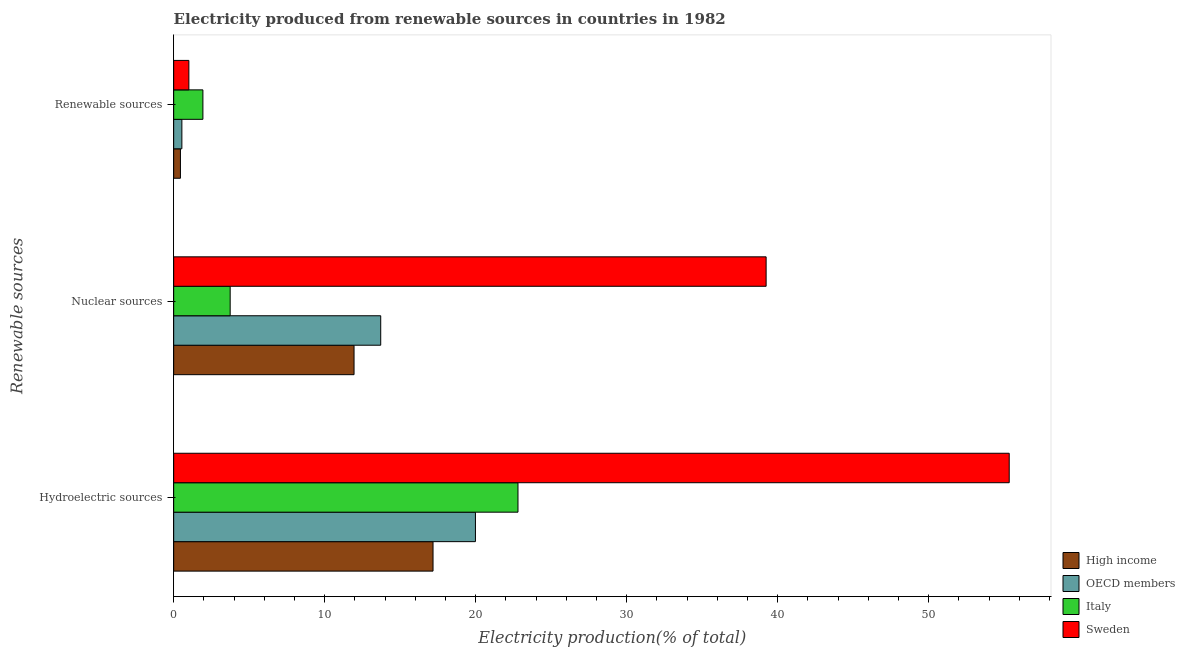How many groups of bars are there?
Make the answer very short. 3. Are the number of bars per tick equal to the number of legend labels?
Keep it short and to the point. Yes. Are the number of bars on each tick of the Y-axis equal?
Keep it short and to the point. Yes. How many bars are there on the 3rd tick from the top?
Provide a succinct answer. 4. How many bars are there on the 3rd tick from the bottom?
Keep it short and to the point. 4. What is the label of the 2nd group of bars from the top?
Give a very brief answer. Nuclear sources. What is the percentage of electricity produced by nuclear sources in OECD members?
Offer a very short reply. 13.71. Across all countries, what is the maximum percentage of electricity produced by nuclear sources?
Offer a terse response. 39.24. Across all countries, what is the minimum percentage of electricity produced by nuclear sources?
Your answer should be compact. 3.74. What is the total percentage of electricity produced by nuclear sources in the graph?
Your answer should be compact. 68.64. What is the difference between the percentage of electricity produced by hydroelectric sources in High income and that in Italy?
Your answer should be very brief. -5.63. What is the difference between the percentage of electricity produced by hydroelectric sources in High income and the percentage of electricity produced by renewable sources in Italy?
Ensure brevity in your answer.  15.24. What is the average percentage of electricity produced by nuclear sources per country?
Give a very brief answer. 17.16. What is the difference between the percentage of electricity produced by renewable sources and percentage of electricity produced by nuclear sources in OECD members?
Ensure brevity in your answer.  -13.17. What is the ratio of the percentage of electricity produced by renewable sources in Sweden to that in Italy?
Provide a short and direct response. 0.52. Is the difference between the percentage of electricity produced by hydroelectric sources in OECD members and Italy greater than the difference between the percentage of electricity produced by nuclear sources in OECD members and Italy?
Your answer should be compact. No. What is the difference between the highest and the second highest percentage of electricity produced by nuclear sources?
Provide a short and direct response. 25.52. What is the difference between the highest and the lowest percentage of electricity produced by nuclear sources?
Your response must be concise. 35.49. In how many countries, is the percentage of electricity produced by renewable sources greater than the average percentage of electricity produced by renewable sources taken over all countries?
Make the answer very short. 2. How many bars are there?
Give a very brief answer. 12. How many countries are there in the graph?
Make the answer very short. 4. What is the difference between two consecutive major ticks on the X-axis?
Keep it short and to the point. 10. Are the values on the major ticks of X-axis written in scientific E-notation?
Provide a succinct answer. No. What is the title of the graph?
Offer a terse response. Electricity produced from renewable sources in countries in 1982. What is the label or title of the X-axis?
Offer a very short reply. Electricity production(% of total). What is the label or title of the Y-axis?
Provide a succinct answer. Renewable sources. What is the Electricity production(% of total) in High income in Hydroelectric sources?
Give a very brief answer. 17.18. What is the Electricity production(% of total) in OECD members in Hydroelectric sources?
Give a very brief answer. 19.99. What is the Electricity production(% of total) of Italy in Hydroelectric sources?
Provide a short and direct response. 22.8. What is the Electricity production(% of total) of Sweden in Hydroelectric sources?
Give a very brief answer. 55.34. What is the Electricity production(% of total) in High income in Nuclear sources?
Provide a short and direct response. 11.95. What is the Electricity production(% of total) in OECD members in Nuclear sources?
Offer a terse response. 13.71. What is the Electricity production(% of total) of Italy in Nuclear sources?
Give a very brief answer. 3.74. What is the Electricity production(% of total) of Sweden in Nuclear sources?
Ensure brevity in your answer.  39.24. What is the Electricity production(% of total) of High income in Renewable sources?
Provide a short and direct response. 0.45. What is the Electricity production(% of total) in OECD members in Renewable sources?
Make the answer very short. 0.54. What is the Electricity production(% of total) of Italy in Renewable sources?
Give a very brief answer. 1.94. What is the Electricity production(% of total) in Sweden in Renewable sources?
Your answer should be very brief. 1.01. Across all Renewable sources, what is the maximum Electricity production(% of total) in High income?
Make the answer very short. 17.18. Across all Renewable sources, what is the maximum Electricity production(% of total) of OECD members?
Provide a succinct answer. 19.99. Across all Renewable sources, what is the maximum Electricity production(% of total) in Italy?
Ensure brevity in your answer.  22.8. Across all Renewable sources, what is the maximum Electricity production(% of total) of Sweden?
Offer a very short reply. 55.34. Across all Renewable sources, what is the minimum Electricity production(% of total) in High income?
Your answer should be compact. 0.45. Across all Renewable sources, what is the minimum Electricity production(% of total) in OECD members?
Provide a succinct answer. 0.54. Across all Renewable sources, what is the minimum Electricity production(% of total) in Italy?
Provide a succinct answer. 1.94. Across all Renewable sources, what is the minimum Electricity production(% of total) in Sweden?
Offer a terse response. 1.01. What is the total Electricity production(% of total) of High income in the graph?
Keep it short and to the point. 29.57. What is the total Electricity production(% of total) of OECD members in the graph?
Make the answer very short. 34.24. What is the total Electricity production(% of total) in Italy in the graph?
Provide a short and direct response. 28.48. What is the total Electricity production(% of total) of Sweden in the graph?
Provide a short and direct response. 95.58. What is the difference between the Electricity production(% of total) in High income in Hydroelectric sources and that in Nuclear sources?
Keep it short and to the point. 5.23. What is the difference between the Electricity production(% of total) of OECD members in Hydroelectric sources and that in Nuclear sources?
Your answer should be compact. 6.27. What is the difference between the Electricity production(% of total) in Italy in Hydroelectric sources and that in Nuclear sources?
Provide a succinct answer. 19.06. What is the difference between the Electricity production(% of total) in Sweden in Hydroelectric sources and that in Nuclear sources?
Ensure brevity in your answer.  16.1. What is the difference between the Electricity production(% of total) of High income in Hydroelectric sources and that in Renewable sources?
Your response must be concise. 16.73. What is the difference between the Electricity production(% of total) of OECD members in Hydroelectric sources and that in Renewable sources?
Make the answer very short. 19.44. What is the difference between the Electricity production(% of total) in Italy in Hydroelectric sources and that in Renewable sources?
Your answer should be compact. 20.87. What is the difference between the Electricity production(% of total) in Sweden in Hydroelectric sources and that in Renewable sources?
Your answer should be compact. 54.33. What is the difference between the Electricity production(% of total) of High income in Nuclear sources and that in Renewable sources?
Provide a succinct answer. 11.5. What is the difference between the Electricity production(% of total) in OECD members in Nuclear sources and that in Renewable sources?
Offer a very short reply. 13.17. What is the difference between the Electricity production(% of total) of Italy in Nuclear sources and that in Renewable sources?
Keep it short and to the point. 1.81. What is the difference between the Electricity production(% of total) in Sweden in Nuclear sources and that in Renewable sources?
Offer a very short reply. 38.23. What is the difference between the Electricity production(% of total) of High income in Hydroelectric sources and the Electricity production(% of total) of OECD members in Nuclear sources?
Give a very brief answer. 3.47. What is the difference between the Electricity production(% of total) of High income in Hydroelectric sources and the Electricity production(% of total) of Italy in Nuclear sources?
Provide a short and direct response. 13.43. What is the difference between the Electricity production(% of total) in High income in Hydroelectric sources and the Electricity production(% of total) in Sweden in Nuclear sources?
Offer a terse response. -22.06. What is the difference between the Electricity production(% of total) in OECD members in Hydroelectric sources and the Electricity production(% of total) in Italy in Nuclear sources?
Your response must be concise. 16.24. What is the difference between the Electricity production(% of total) in OECD members in Hydroelectric sources and the Electricity production(% of total) in Sweden in Nuclear sources?
Your answer should be very brief. -19.25. What is the difference between the Electricity production(% of total) in Italy in Hydroelectric sources and the Electricity production(% of total) in Sweden in Nuclear sources?
Your answer should be compact. -16.43. What is the difference between the Electricity production(% of total) in High income in Hydroelectric sources and the Electricity production(% of total) in OECD members in Renewable sources?
Offer a very short reply. 16.63. What is the difference between the Electricity production(% of total) in High income in Hydroelectric sources and the Electricity production(% of total) in Italy in Renewable sources?
Provide a succinct answer. 15.24. What is the difference between the Electricity production(% of total) of High income in Hydroelectric sources and the Electricity production(% of total) of Sweden in Renewable sources?
Keep it short and to the point. 16.17. What is the difference between the Electricity production(% of total) in OECD members in Hydroelectric sources and the Electricity production(% of total) in Italy in Renewable sources?
Offer a terse response. 18.05. What is the difference between the Electricity production(% of total) of OECD members in Hydroelectric sources and the Electricity production(% of total) of Sweden in Renewable sources?
Your answer should be compact. 18.98. What is the difference between the Electricity production(% of total) of Italy in Hydroelectric sources and the Electricity production(% of total) of Sweden in Renewable sources?
Keep it short and to the point. 21.8. What is the difference between the Electricity production(% of total) in High income in Nuclear sources and the Electricity production(% of total) in OECD members in Renewable sources?
Give a very brief answer. 11.4. What is the difference between the Electricity production(% of total) in High income in Nuclear sources and the Electricity production(% of total) in Italy in Renewable sources?
Offer a very short reply. 10.01. What is the difference between the Electricity production(% of total) in High income in Nuclear sources and the Electricity production(% of total) in Sweden in Renewable sources?
Offer a terse response. 10.94. What is the difference between the Electricity production(% of total) in OECD members in Nuclear sources and the Electricity production(% of total) in Italy in Renewable sources?
Provide a short and direct response. 11.78. What is the difference between the Electricity production(% of total) in OECD members in Nuclear sources and the Electricity production(% of total) in Sweden in Renewable sources?
Ensure brevity in your answer.  12.7. What is the difference between the Electricity production(% of total) in Italy in Nuclear sources and the Electricity production(% of total) in Sweden in Renewable sources?
Offer a very short reply. 2.74. What is the average Electricity production(% of total) of High income per Renewable sources?
Give a very brief answer. 9.86. What is the average Electricity production(% of total) in OECD members per Renewable sources?
Offer a very short reply. 11.41. What is the average Electricity production(% of total) of Italy per Renewable sources?
Your answer should be compact. 9.49. What is the average Electricity production(% of total) in Sweden per Renewable sources?
Keep it short and to the point. 31.86. What is the difference between the Electricity production(% of total) in High income and Electricity production(% of total) in OECD members in Hydroelectric sources?
Ensure brevity in your answer.  -2.81. What is the difference between the Electricity production(% of total) of High income and Electricity production(% of total) of Italy in Hydroelectric sources?
Offer a terse response. -5.63. What is the difference between the Electricity production(% of total) of High income and Electricity production(% of total) of Sweden in Hydroelectric sources?
Your response must be concise. -38.16. What is the difference between the Electricity production(% of total) of OECD members and Electricity production(% of total) of Italy in Hydroelectric sources?
Your answer should be compact. -2.82. What is the difference between the Electricity production(% of total) in OECD members and Electricity production(% of total) in Sweden in Hydroelectric sources?
Provide a short and direct response. -35.35. What is the difference between the Electricity production(% of total) in Italy and Electricity production(% of total) in Sweden in Hydroelectric sources?
Give a very brief answer. -32.53. What is the difference between the Electricity production(% of total) in High income and Electricity production(% of total) in OECD members in Nuclear sources?
Ensure brevity in your answer.  -1.77. What is the difference between the Electricity production(% of total) in High income and Electricity production(% of total) in Italy in Nuclear sources?
Offer a very short reply. 8.2. What is the difference between the Electricity production(% of total) of High income and Electricity production(% of total) of Sweden in Nuclear sources?
Provide a succinct answer. -27.29. What is the difference between the Electricity production(% of total) in OECD members and Electricity production(% of total) in Italy in Nuclear sources?
Provide a succinct answer. 9.97. What is the difference between the Electricity production(% of total) in OECD members and Electricity production(% of total) in Sweden in Nuclear sources?
Provide a succinct answer. -25.52. What is the difference between the Electricity production(% of total) of Italy and Electricity production(% of total) of Sweden in Nuclear sources?
Offer a terse response. -35.49. What is the difference between the Electricity production(% of total) in High income and Electricity production(% of total) in OECD members in Renewable sources?
Your response must be concise. -0.1. What is the difference between the Electricity production(% of total) in High income and Electricity production(% of total) in Italy in Renewable sources?
Provide a succinct answer. -1.49. What is the difference between the Electricity production(% of total) in High income and Electricity production(% of total) in Sweden in Renewable sources?
Your answer should be compact. -0.56. What is the difference between the Electricity production(% of total) of OECD members and Electricity production(% of total) of Italy in Renewable sources?
Give a very brief answer. -1.39. What is the difference between the Electricity production(% of total) of OECD members and Electricity production(% of total) of Sweden in Renewable sources?
Offer a terse response. -0.46. What is the difference between the Electricity production(% of total) of Italy and Electricity production(% of total) of Sweden in Renewable sources?
Provide a succinct answer. 0.93. What is the ratio of the Electricity production(% of total) in High income in Hydroelectric sources to that in Nuclear sources?
Keep it short and to the point. 1.44. What is the ratio of the Electricity production(% of total) in OECD members in Hydroelectric sources to that in Nuclear sources?
Your answer should be compact. 1.46. What is the ratio of the Electricity production(% of total) of Italy in Hydroelectric sources to that in Nuclear sources?
Give a very brief answer. 6.09. What is the ratio of the Electricity production(% of total) of Sweden in Hydroelectric sources to that in Nuclear sources?
Provide a short and direct response. 1.41. What is the ratio of the Electricity production(% of total) of High income in Hydroelectric sources to that in Renewable sources?
Give a very brief answer. 38.36. What is the ratio of the Electricity production(% of total) of OECD members in Hydroelectric sources to that in Renewable sources?
Ensure brevity in your answer.  36.77. What is the ratio of the Electricity production(% of total) of Italy in Hydroelectric sources to that in Renewable sources?
Your answer should be very brief. 11.78. What is the ratio of the Electricity production(% of total) of Sweden in Hydroelectric sources to that in Renewable sources?
Ensure brevity in your answer.  54.96. What is the ratio of the Electricity production(% of total) of High income in Nuclear sources to that in Renewable sources?
Your answer should be compact. 26.68. What is the ratio of the Electricity production(% of total) in OECD members in Nuclear sources to that in Renewable sources?
Offer a very short reply. 25.22. What is the ratio of the Electricity production(% of total) in Italy in Nuclear sources to that in Renewable sources?
Offer a terse response. 1.93. What is the ratio of the Electricity production(% of total) of Sweden in Nuclear sources to that in Renewable sources?
Keep it short and to the point. 38.97. What is the difference between the highest and the second highest Electricity production(% of total) in High income?
Ensure brevity in your answer.  5.23. What is the difference between the highest and the second highest Electricity production(% of total) in OECD members?
Keep it short and to the point. 6.27. What is the difference between the highest and the second highest Electricity production(% of total) of Italy?
Make the answer very short. 19.06. What is the difference between the highest and the second highest Electricity production(% of total) in Sweden?
Offer a very short reply. 16.1. What is the difference between the highest and the lowest Electricity production(% of total) in High income?
Provide a succinct answer. 16.73. What is the difference between the highest and the lowest Electricity production(% of total) of OECD members?
Ensure brevity in your answer.  19.44. What is the difference between the highest and the lowest Electricity production(% of total) in Italy?
Give a very brief answer. 20.87. What is the difference between the highest and the lowest Electricity production(% of total) in Sweden?
Provide a succinct answer. 54.33. 